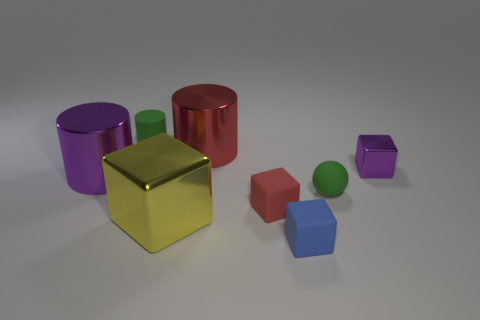There is a ball; does it have the same color as the cube that is on the right side of the blue matte cube? no 